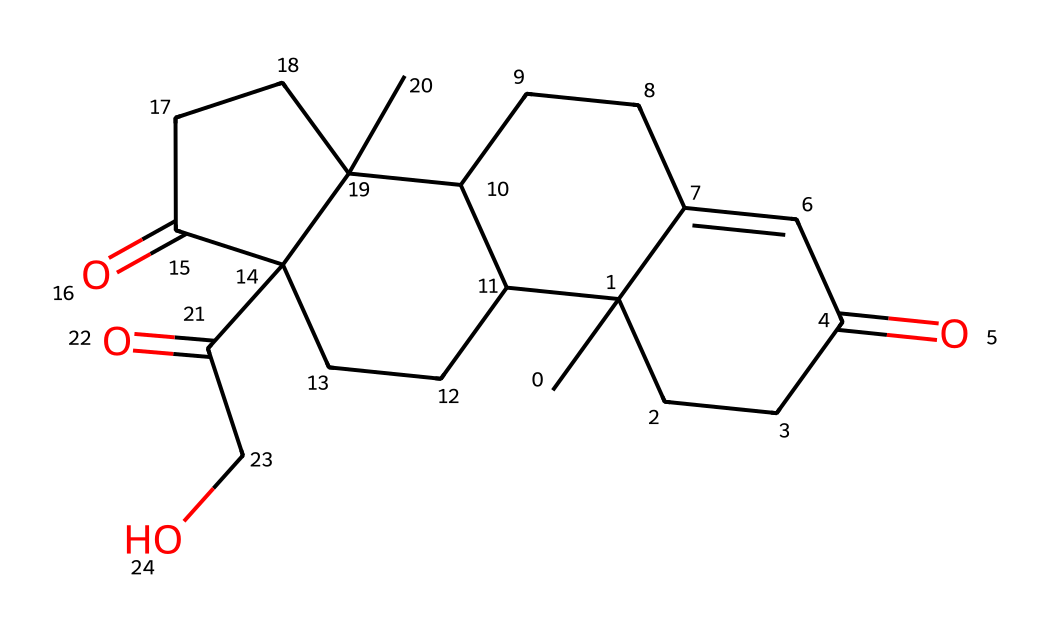What is the molecular formula of cortisol? To determine the molecular formula, I counted the number of carbon (C), hydrogen (H), and oxygen (O) atoms in the structure. The visual representation indicates 21 carbon atoms, 30 hydrogen atoms, and 5 oxygen atoms. Thus, the molecular formula is C21H30O5.
Answer: C21H30O5 How many rings are present in the structure of cortisol? By examining the structure, I identified four interconnected ring structures that comprise the steroid framework typical of cortisol. Thus, I counted four rings.
Answer: 4 What type of functional groups are present in cortisol? In the structure of cortisol, I looked for specific features such as hydroxyl (OH) groups and carbonyl (C=O) groups. The presence of two ketones (indicated by >C=O) and one alcohol (-OH) group qualifies cortisol as having ketone and alcohol functional groups.
Answer: ketone and alcohol What is the significance of cortisol for e-commerce entrepreneurs? Cortisol, being a stress hormone, is significant because elevated levels may affect decision-making, productivity, and overall well-being, which are critical aspects for someone managing an online business.
Answer: stress hormone What kind of chemical compound is cortisol classified as? Given its structure and functionality, cortisol is classified as a steroid hormone since it is derived from cholesterol and has the typical steroid ring structure.
Answer: steroid hormone 